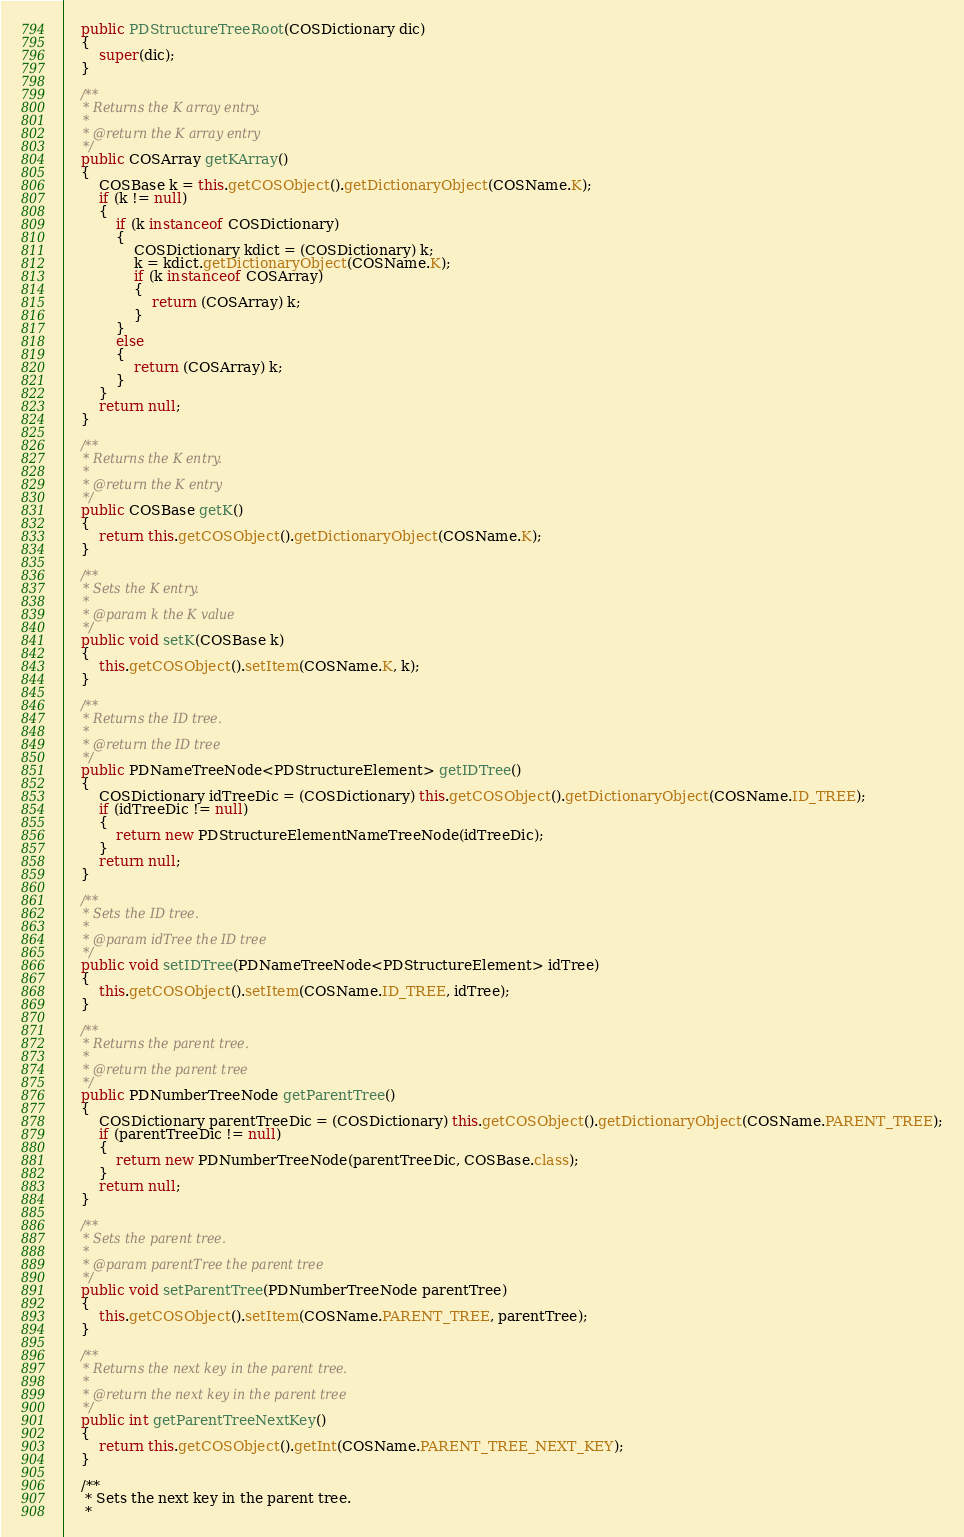<code> <loc_0><loc_0><loc_500><loc_500><_Java_>    public PDStructureTreeRoot(COSDictionary dic)
    {
        super(dic);
    }

    /**
     * Returns the K array entry.
     *
     * @return the K array entry
     */
    public COSArray getKArray()
    {
        COSBase k = this.getCOSObject().getDictionaryObject(COSName.K);
        if (k != null)
        {
            if (k instanceof COSDictionary)
            {
                COSDictionary kdict = (COSDictionary) k;
                k = kdict.getDictionaryObject(COSName.K);
                if (k instanceof COSArray)
                {
                    return (COSArray) k;
                }
            }
            else
            {
                return (COSArray) k;
            }
        }
        return null;
    }

    /**
     * Returns the K entry.
     *
     * @return the K entry
     */
    public COSBase getK()
    {
        return this.getCOSObject().getDictionaryObject(COSName.K);
    }

    /**
     * Sets the K entry.
     *
     * @param k the K value
     */
    public void setK(COSBase k)
    {
        this.getCOSObject().setItem(COSName.K, k);
    }

    /**
     * Returns the ID tree.
     *
     * @return the ID tree
     */
    public PDNameTreeNode<PDStructureElement> getIDTree()
    {
        COSDictionary idTreeDic = (COSDictionary) this.getCOSObject().getDictionaryObject(COSName.ID_TREE);
        if (idTreeDic != null)
        {
            return new PDStructureElementNameTreeNode(idTreeDic);
        }
        return null;
    }

    /**
     * Sets the ID tree.
     *
     * @param idTree the ID tree
     */
    public void setIDTree(PDNameTreeNode<PDStructureElement> idTree)
    {
        this.getCOSObject().setItem(COSName.ID_TREE, idTree);
    }

    /**
     * Returns the parent tree.
     *
     * @return the parent tree
     */
    public PDNumberTreeNode getParentTree()
    {
        COSDictionary parentTreeDic = (COSDictionary) this.getCOSObject().getDictionaryObject(COSName.PARENT_TREE);
        if (parentTreeDic != null)
        {
            return new PDNumberTreeNode(parentTreeDic, COSBase.class);
        }
        return null;
    }

    /**
     * Sets the parent tree.
     *
     * @param parentTree the parent tree
     */
    public void setParentTree(PDNumberTreeNode parentTree)
    {
        this.getCOSObject().setItem(COSName.PARENT_TREE, parentTree);
    }

    /**
     * Returns the next key in the parent tree.
     *
     * @return the next key in the parent tree
     */
    public int getParentTreeNextKey()
    {
        return this.getCOSObject().getInt(COSName.PARENT_TREE_NEXT_KEY);
    }

    /**
     * Sets the next key in the parent tree.
     *</code> 